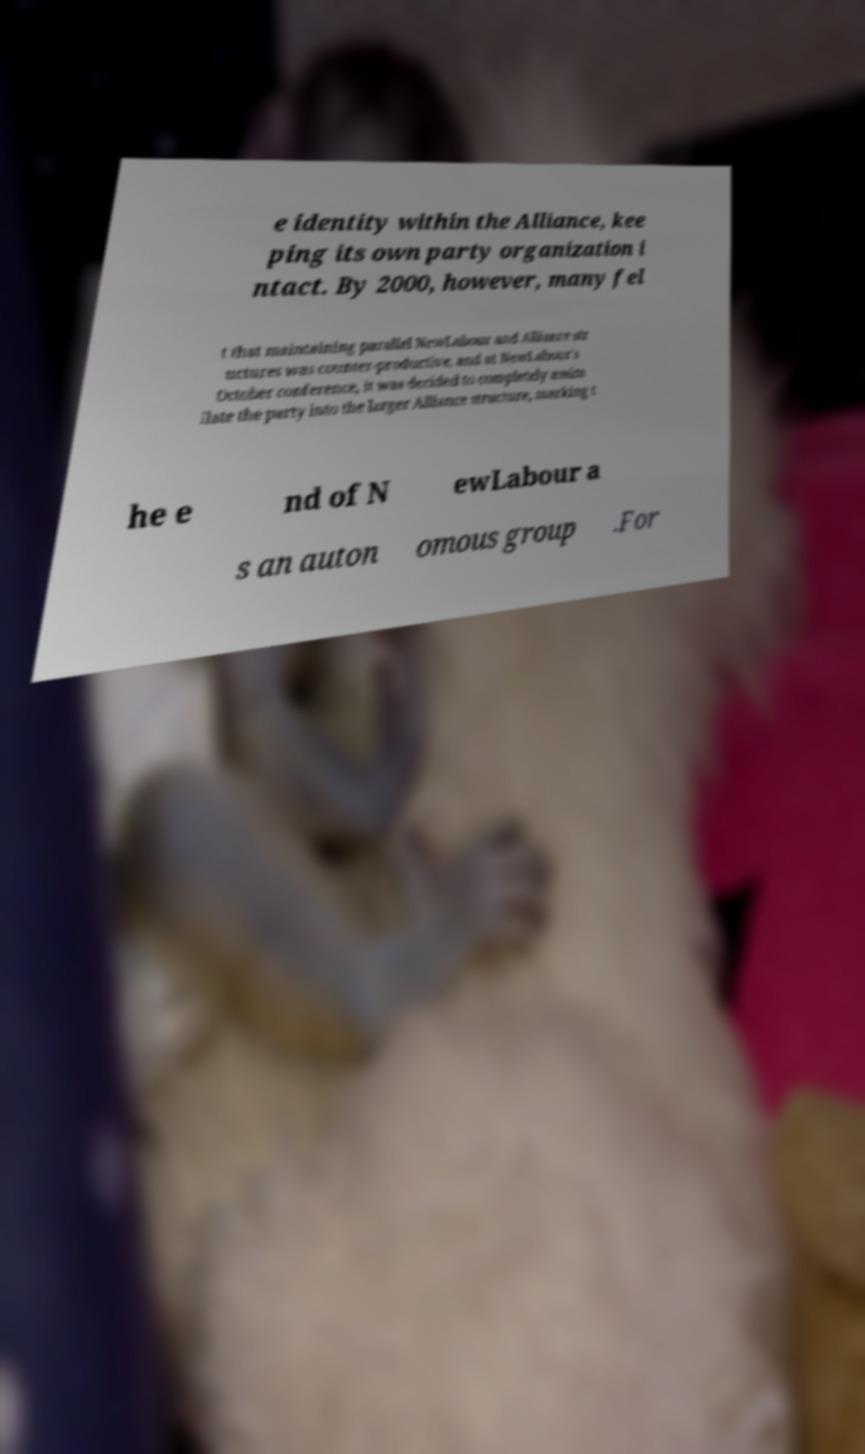For documentation purposes, I need the text within this image transcribed. Could you provide that? e identity within the Alliance, kee ping its own party organization i ntact. By 2000, however, many fel t that maintaining parallel NewLabour and Alliance str uctures was counter-productive, and at NewLabour's October conference, it was decided to completely assim ilate the party into the larger Alliance structure, marking t he e nd of N ewLabour a s an auton omous group .For 